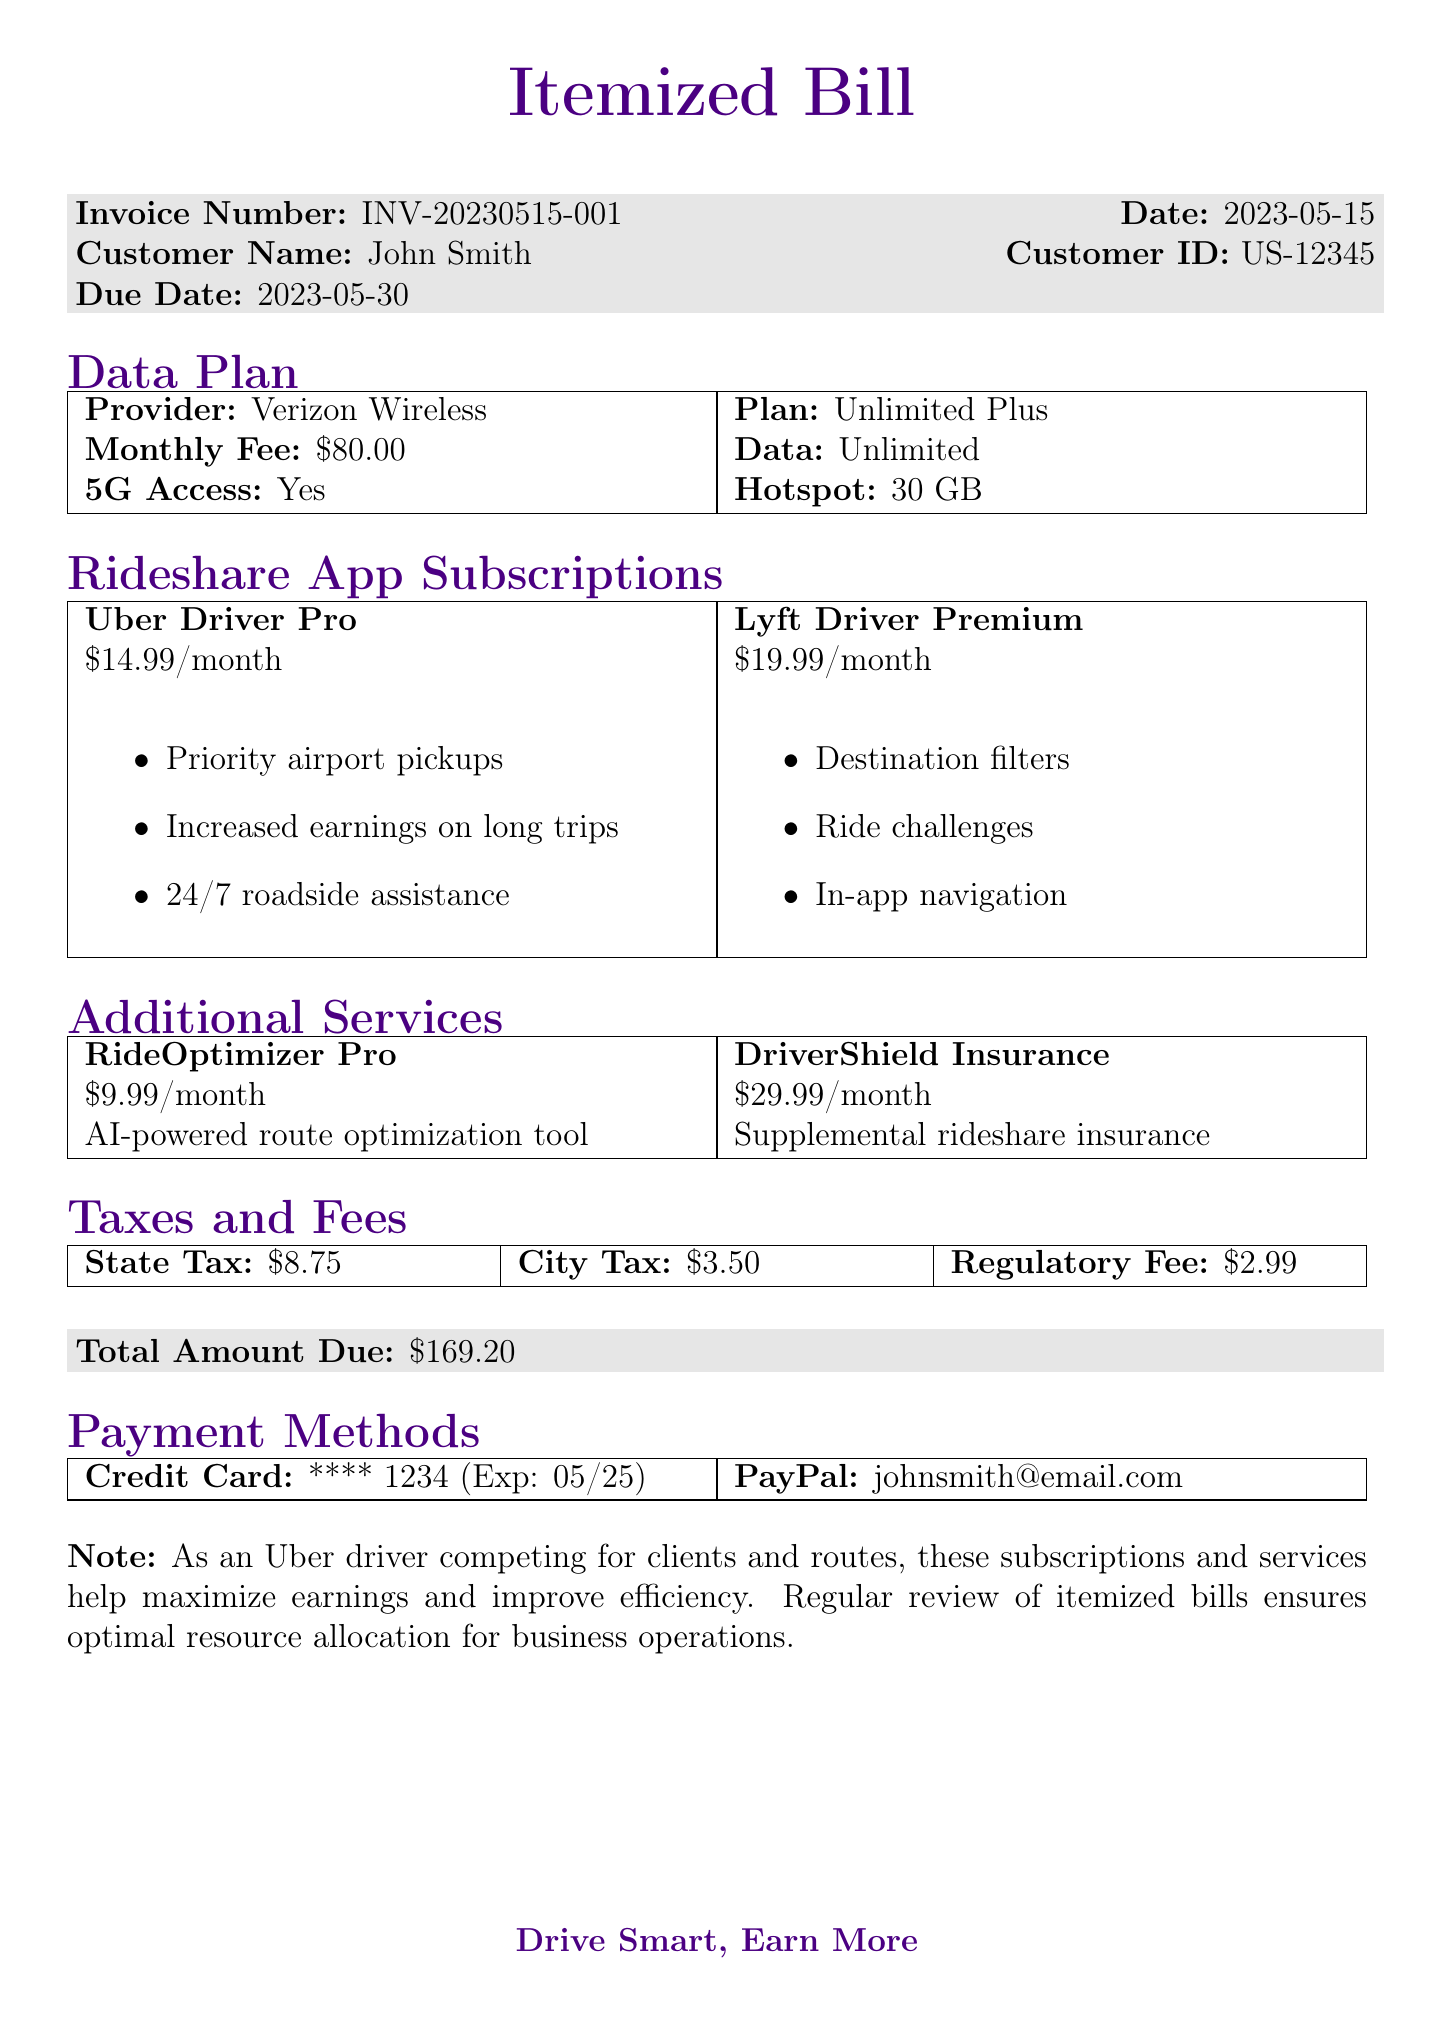What is the invoice number? The invoice number is a unique identifier for the bill, which is provided in the document.
Answer: INV-20230515-001 What is the due date for the invoice? The due date specifies when the payment for the invoice is required.
Answer: 2023-05-30 Which provider offers the data plan? The document includes details about the data plan provider, which is important for identifying services.
Answer: Verizon Wireless What is the monthly fee for the Lyft Driver subscription? This fee represents the cost for accessing the features related to the Lyft Driver app.
Answer: 19.99 How many gigabytes of hotspot data does the data plan provide? The amount of hotspot data included in the data plan indicates its value for users requiring internet access on the go.
Answer: 30 GB What is the total amount due on the invoice? The total amount represents the final balance that needs to be paid by the customer, summarizing all charges.
Answer: 169.20 What features are included in the Uber Driver subscription? This question highlights the specific benefits provided to the user, showing the value of the subscription.
Answer: Priority airport pickups, Increased earnings on long trips, 24/7 roadside assistance Which service has a description of "AI-powered route optimization tool"? This identifies an additional service included in the invoice, important for understanding the offerings.
Answer: RideOptimizer Pro What type of payment methods are accepted? The document lists the various ways in which payment can be made for the invoice.
Answer: Credit Card, PayPal 